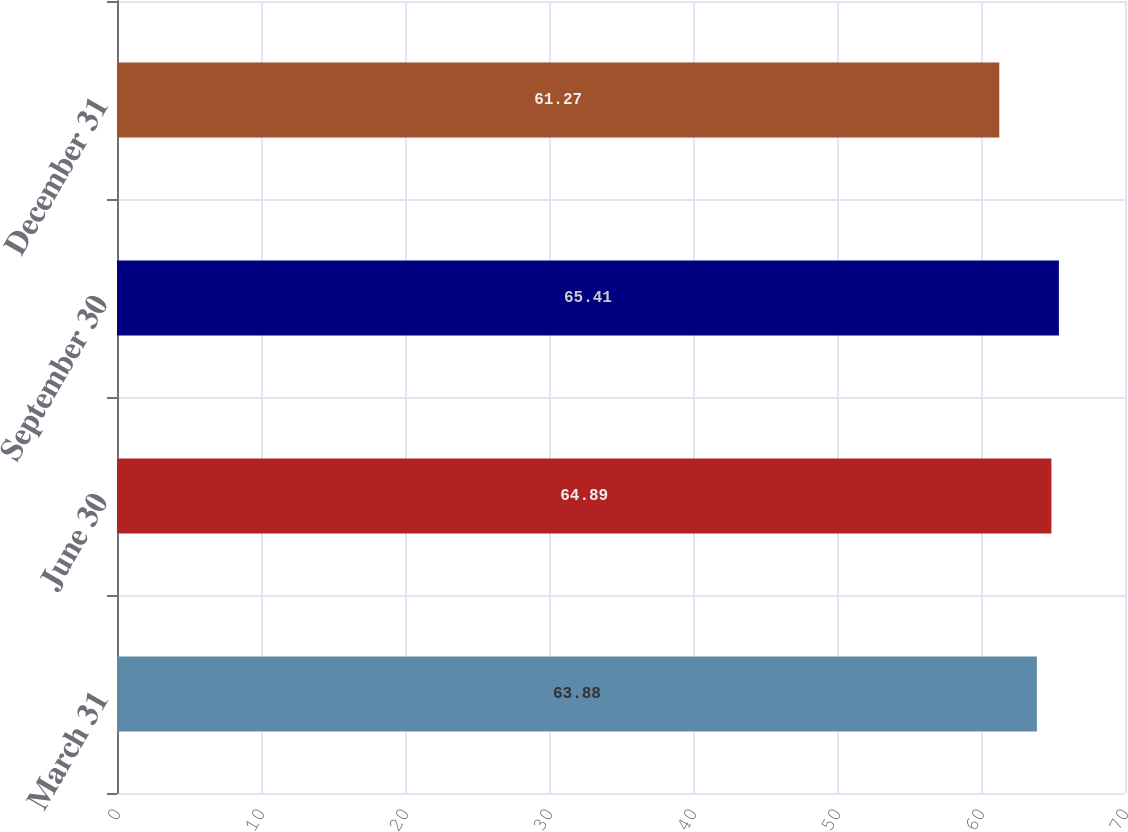Convert chart. <chart><loc_0><loc_0><loc_500><loc_500><bar_chart><fcel>March 31<fcel>June 30<fcel>September 30<fcel>December 31<nl><fcel>63.88<fcel>64.89<fcel>65.41<fcel>61.27<nl></chart> 